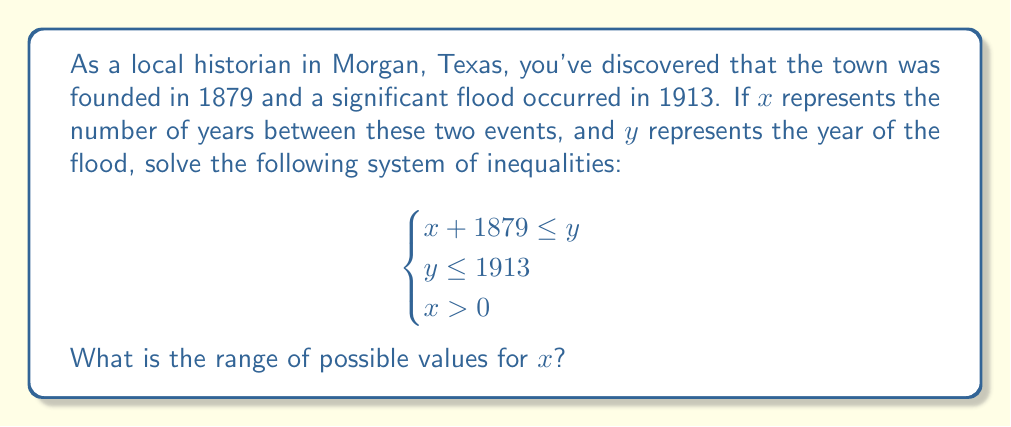What is the answer to this math problem? Let's approach this step-by-step:

1) From the first inequality, we have:
   $x + 1879 \leq y$

2) From the second inequality:
   $y \leq 1913$

3) Combining these two inequalities:
   $x + 1879 \leq y \leq 1913$

4) We can simplify this to:
   $x + 1879 \leq 1913$

5) Subtracting 1879 from both sides:
   $x \leq 34$

6) From the third given inequality, we know that $x > 0$

7) Combining the results from steps 5 and 6, we get:
   $0 < x \leq 34$

This inequality represents the range of possible values for $x$, which is the number of years between the town's founding and the flood.
Answer: The range of possible values for $x$ is $0 < x \leq 34$ years. 